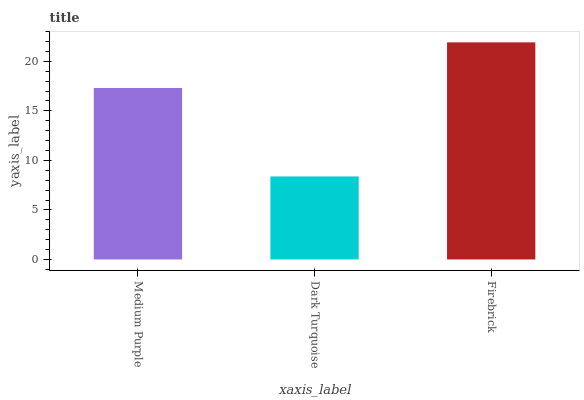Is Dark Turquoise the minimum?
Answer yes or no. Yes. Is Firebrick the maximum?
Answer yes or no. Yes. Is Firebrick the minimum?
Answer yes or no. No. Is Dark Turquoise the maximum?
Answer yes or no. No. Is Firebrick greater than Dark Turquoise?
Answer yes or no. Yes. Is Dark Turquoise less than Firebrick?
Answer yes or no. Yes. Is Dark Turquoise greater than Firebrick?
Answer yes or no. No. Is Firebrick less than Dark Turquoise?
Answer yes or no. No. Is Medium Purple the high median?
Answer yes or no. Yes. Is Medium Purple the low median?
Answer yes or no. Yes. Is Firebrick the high median?
Answer yes or no. No. Is Firebrick the low median?
Answer yes or no. No. 